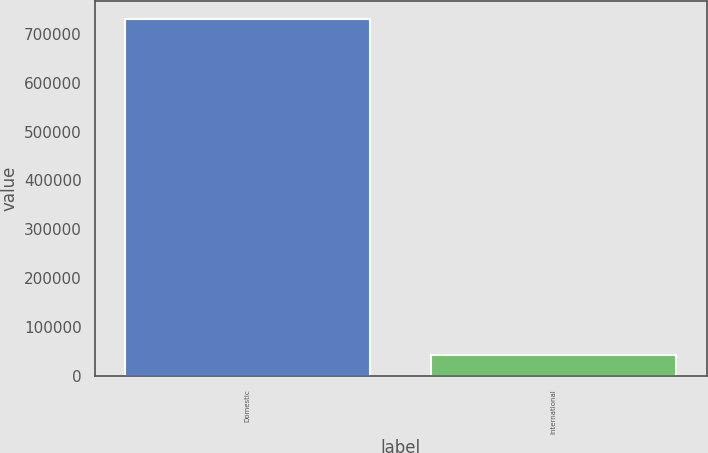Convert chart. <chart><loc_0><loc_0><loc_500><loc_500><bar_chart><fcel>Domestic<fcel>International<nl><fcel>730249<fcel>41862<nl></chart> 